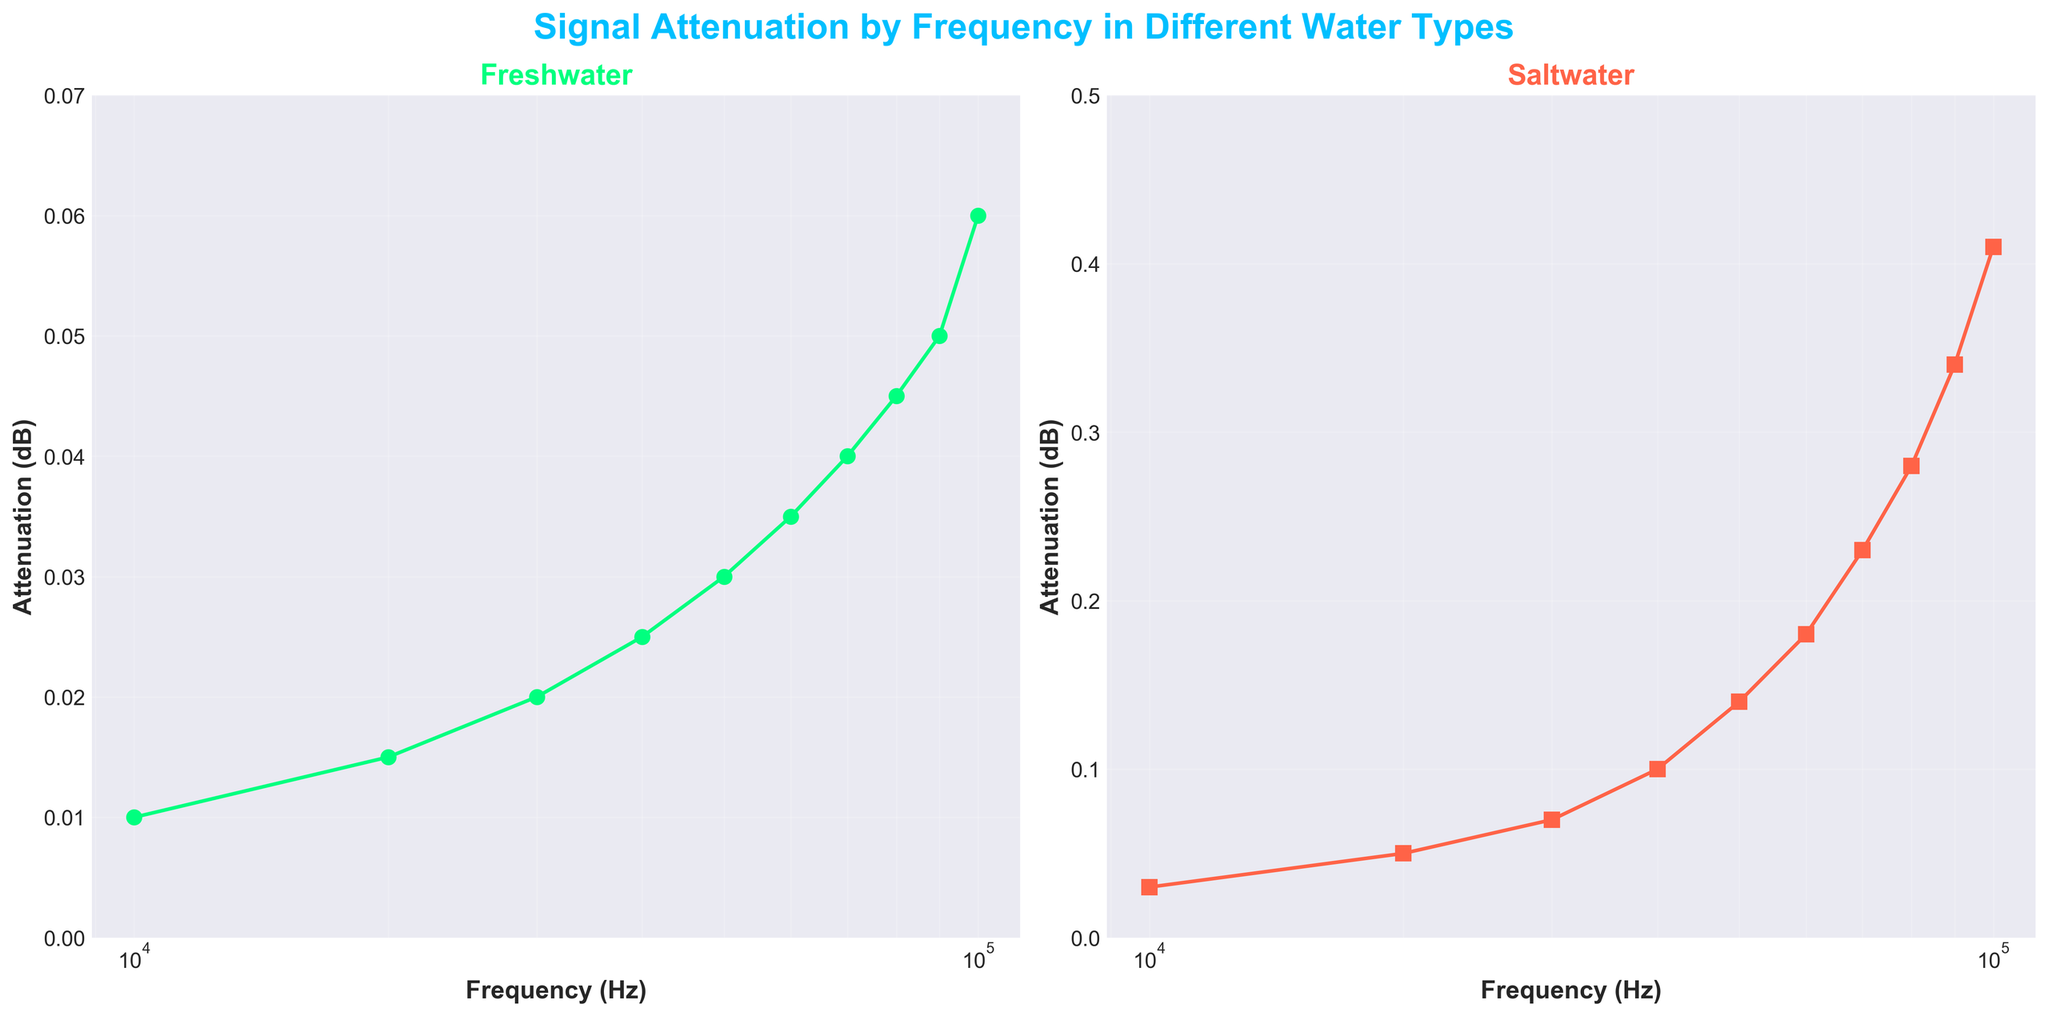What is the title of the figure? The title of the figure is displayed at the top and it reads "Signal Attenuation by Frequency in Different Water Types".
Answer: Signal Attenuation by Frequency in Different Water Types What is the attenuation in saltwater at 40,000 Hz? Look at the second subplot labeled "Saltwater" and find the data point for a frequency of 40,000 Hz. The corresponding attenuation value is around 0.1 dB.
Answer: 0.1 dB How does attenuation at 100,000 Hz in saltwater compare to that in freshwater? Compare the attenuation values at 100,000 Hz in both subplots. In saltwater, the attenuation is around 0.41 dB, while in freshwater it is about 0.06 dB. Therefore, attenuation in saltwater is higher.
Answer: Saltwater has higher attenuation, 0.41 dB vs 0.06 dB Which subplot has a steeper increase in attenuation with frequency, and why might that be significant for underwater communication? By examining the slopes, it is clear that the rate of increase in attenuation is steeper in the saltwater subplot. This might be significant because it suggests higher signal loss in saltwater, affecting the efficiency of underwater communication systems.
Answer: Saltwater; higher signal loss What is the difference in attenuation at 60,000 Hz between freshwater and saltwater? Locate the attenuation values for 60,000 Hz on both subplots. In freshwater it is about 0.035 dB, and in saltwater it is about 0.18 dB. Subtract the freshwater value from the saltwater value.
Answer: 0.145 dB What can you infer about the relationship between frequency and attenuation in both water types? Observing both subplots, it is evident that attenuation increases with frequency in both freshwater and saltwater. This indicates a positive correlation between frequency and attenuation in both water types.
Answer: Positive correlation in both What are the y-axis limits of the freshwater subplot? Look at the y-axis of the freshwater subplot, which scales from 0 to around 0.07 dB.
Answer: 0 to 0.07 dB How do the markers differ between the freshwater and saltwater subplots? In the freshwater subplot, the markers are circular, while in the saltwater subplot, the markers are square-shaped. This distinguishes the visual representation of the data points.
Answer: Circular in freshwater, square in saltwater Why might the plot use a logarithmic scale for the x-axis? A logarithmic scale is useful for visualizing data spanning several orders of magnitude, such as frequency in this case. It can make trends easier to identify when working with a broad range of frequencies.
Answer: To visualize data with broad frequency range 